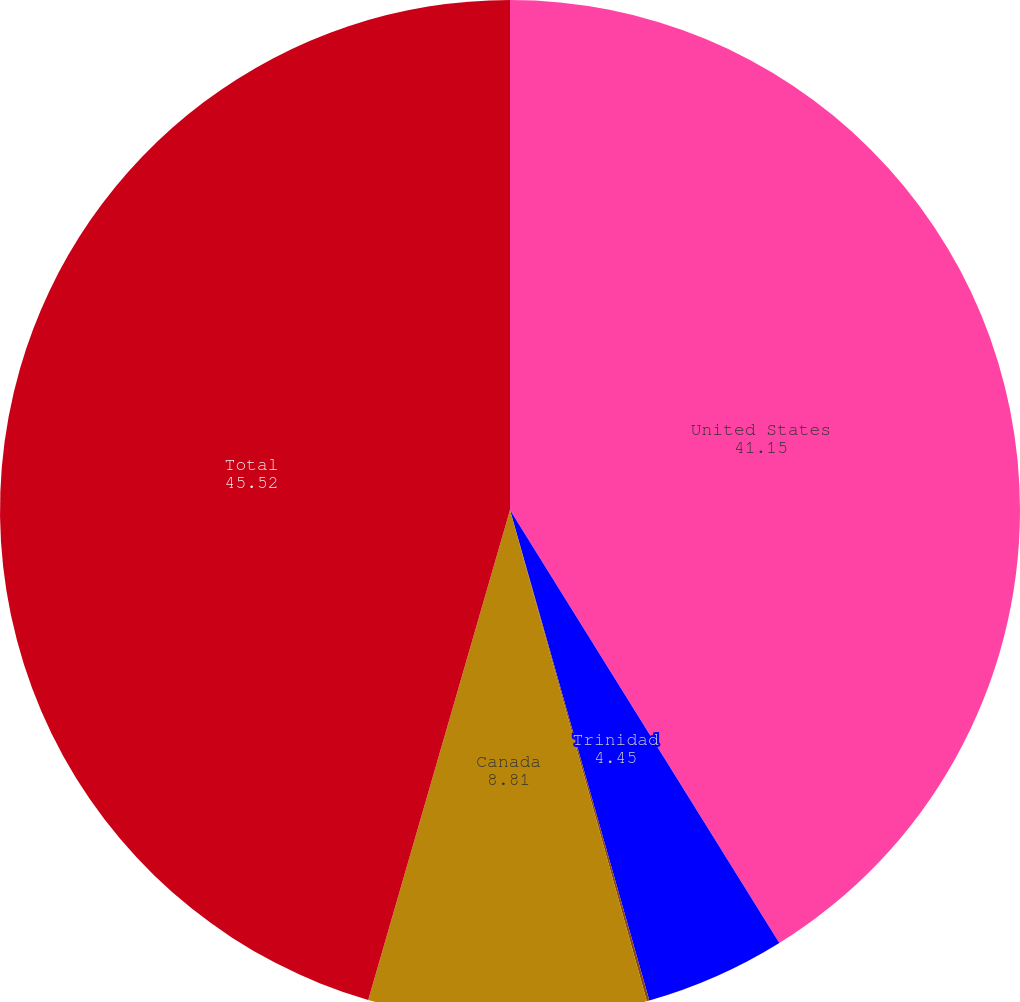<chart> <loc_0><loc_0><loc_500><loc_500><pie_chart><fcel>United States<fcel>Trinidad<fcel>United Kingdom<fcel>Canada<fcel>Total<nl><fcel>41.15%<fcel>4.45%<fcel>0.08%<fcel>8.81%<fcel>45.52%<nl></chart> 